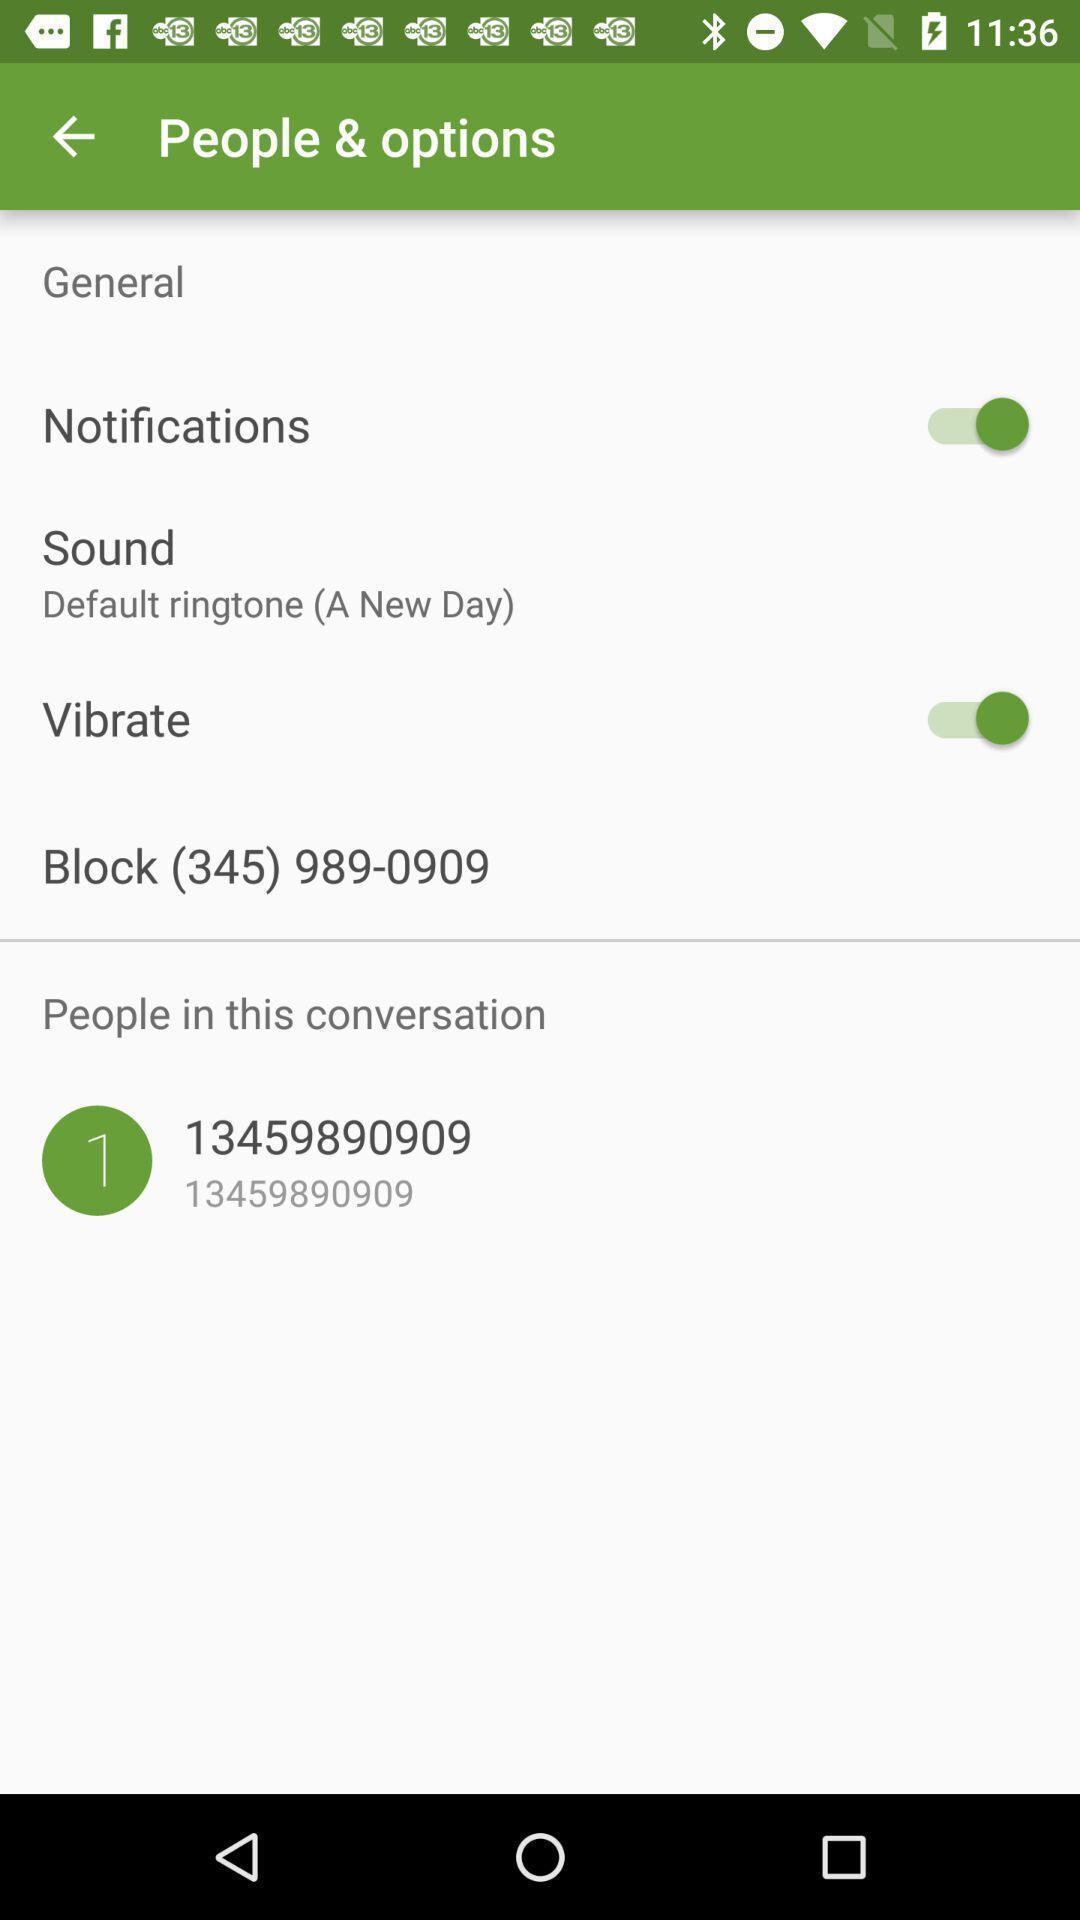Provide a textual representation of this image. Settings page with general options to edit a contact. 